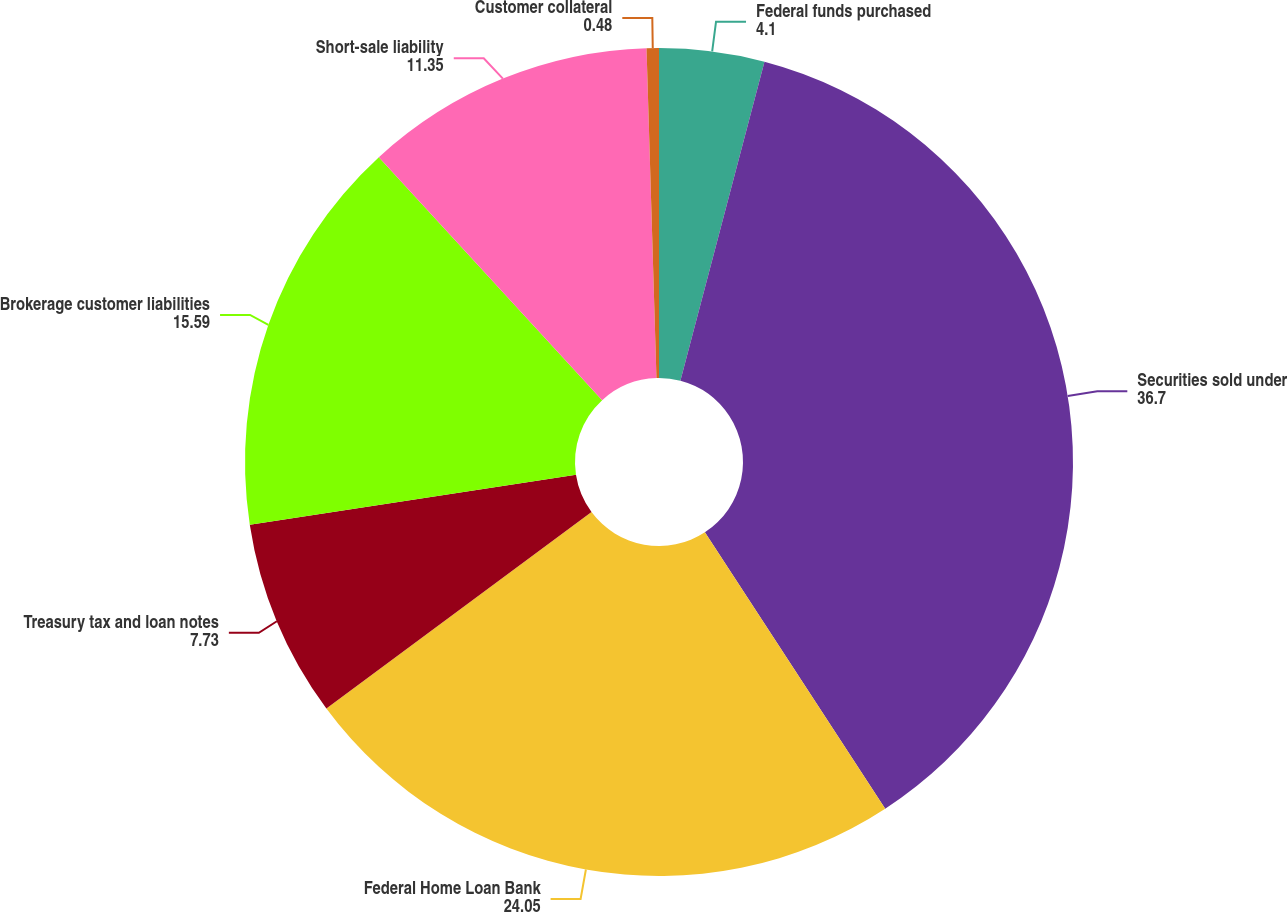<chart> <loc_0><loc_0><loc_500><loc_500><pie_chart><fcel>Federal funds purchased<fcel>Securities sold under<fcel>Federal Home Loan Bank<fcel>Treasury tax and loan notes<fcel>Brokerage customer liabilities<fcel>Short-sale liability<fcel>Customer collateral<nl><fcel>4.1%<fcel>36.7%<fcel>24.05%<fcel>7.73%<fcel>15.59%<fcel>11.35%<fcel>0.48%<nl></chart> 